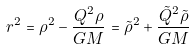Convert formula to latex. <formula><loc_0><loc_0><loc_500><loc_500>r ^ { 2 } = \rho ^ { 2 } - \frac { Q ^ { 2 } \rho } { G M } = { \tilde { \rho } } ^ { 2 } + \frac { { \tilde { Q } } ^ { 2 } { \tilde { \rho } } } { G M }</formula> 